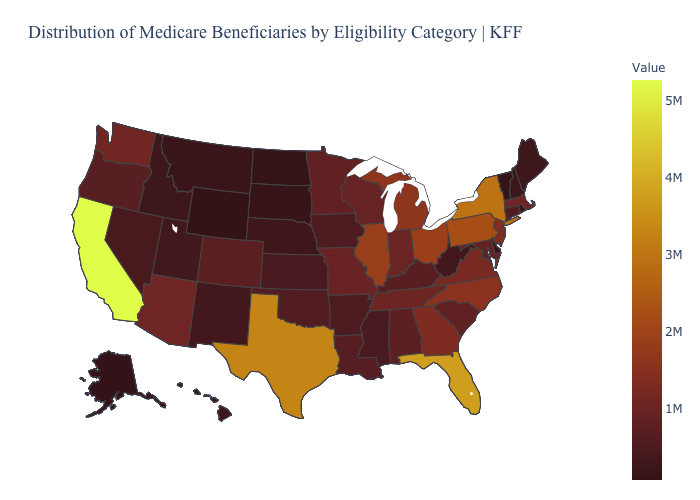Which states have the lowest value in the South?
Concise answer only. Delaware. Which states have the lowest value in the West?
Concise answer only. Alaska. Which states have the lowest value in the MidWest?
Concise answer only. North Dakota. Does Wisconsin have a higher value than Nebraska?
Short answer required. Yes. Among the states that border Massachusetts , does Vermont have the lowest value?
Give a very brief answer. Yes. 